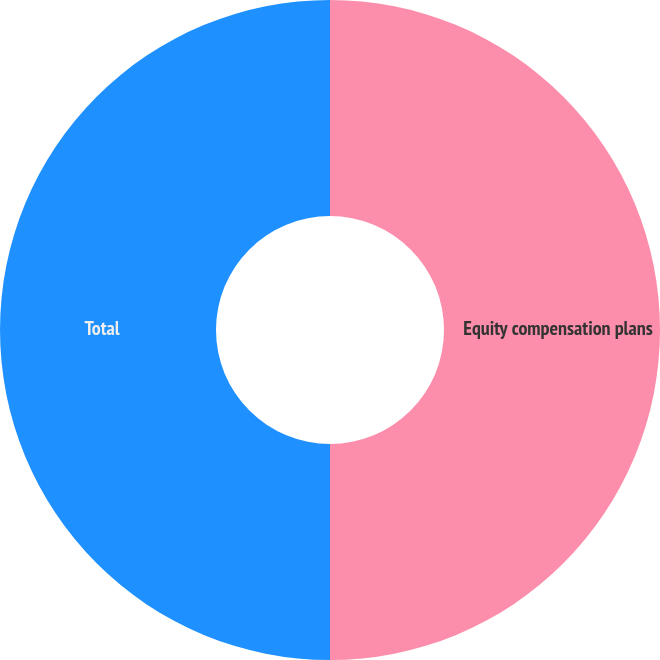Convert chart. <chart><loc_0><loc_0><loc_500><loc_500><pie_chart><fcel>Equity compensation plans<fcel>Total<nl><fcel>50.0%<fcel>50.0%<nl></chart> 